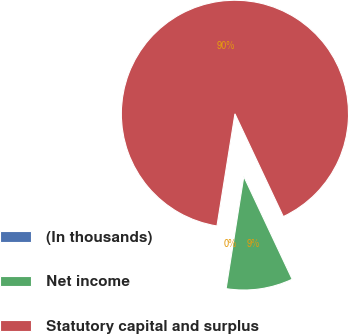<chart> <loc_0><loc_0><loc_500><loc_500><pie_chart><fcel>(In thousands)<fcel>Net income<fcel>Statutory capital and surplus<nl><fcel>0.04%<fcel>9.49%<fcel>90.47%<nl></chart> 